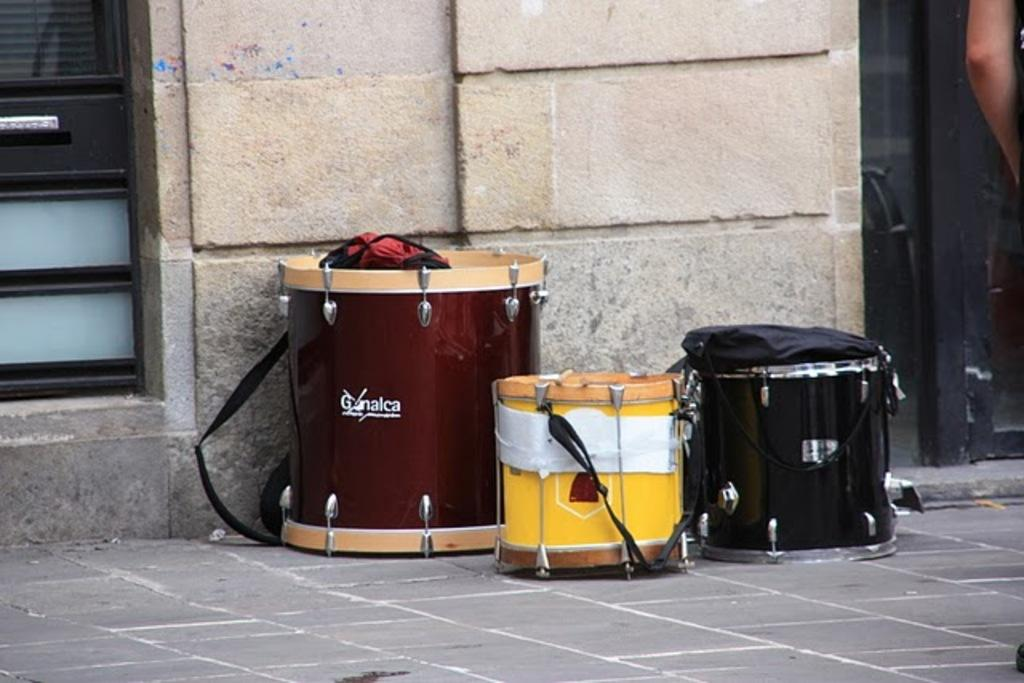<image>
Give a short and clear explanation of the subsequent image. A couple of drums sit next to a building including one from Ganalca. 